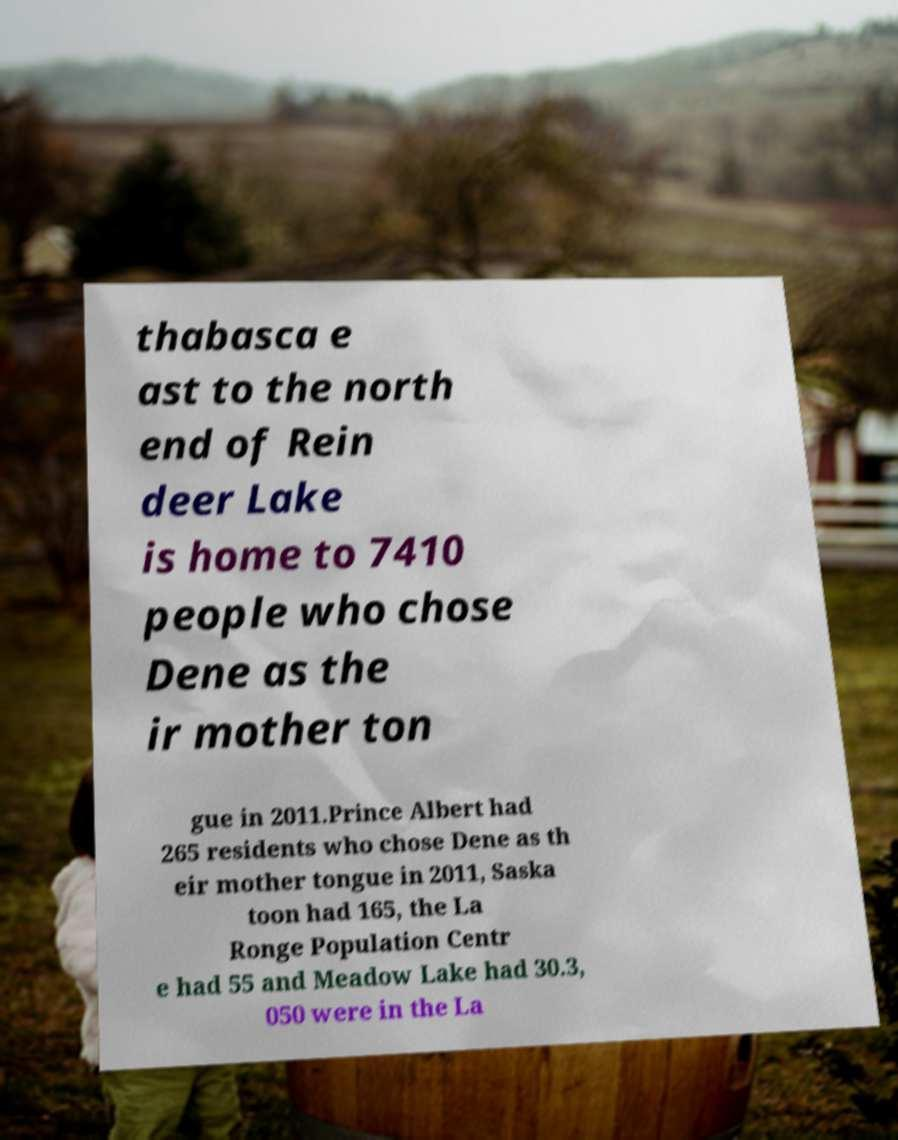Can you accurately transcribe the text from the provided image for me? thabasca e ast to the north end of Rein deer Lake is home to 7410 people who chose Dene as the ir mother ton gue in 2011.Prince Albert had 265 residents who chose Dene as th eir mother tongue in 2011, Saska toon had 165, the La Ronge Population Centr e had 55 and Meadow Lake had 30.3, 050 were in the La 